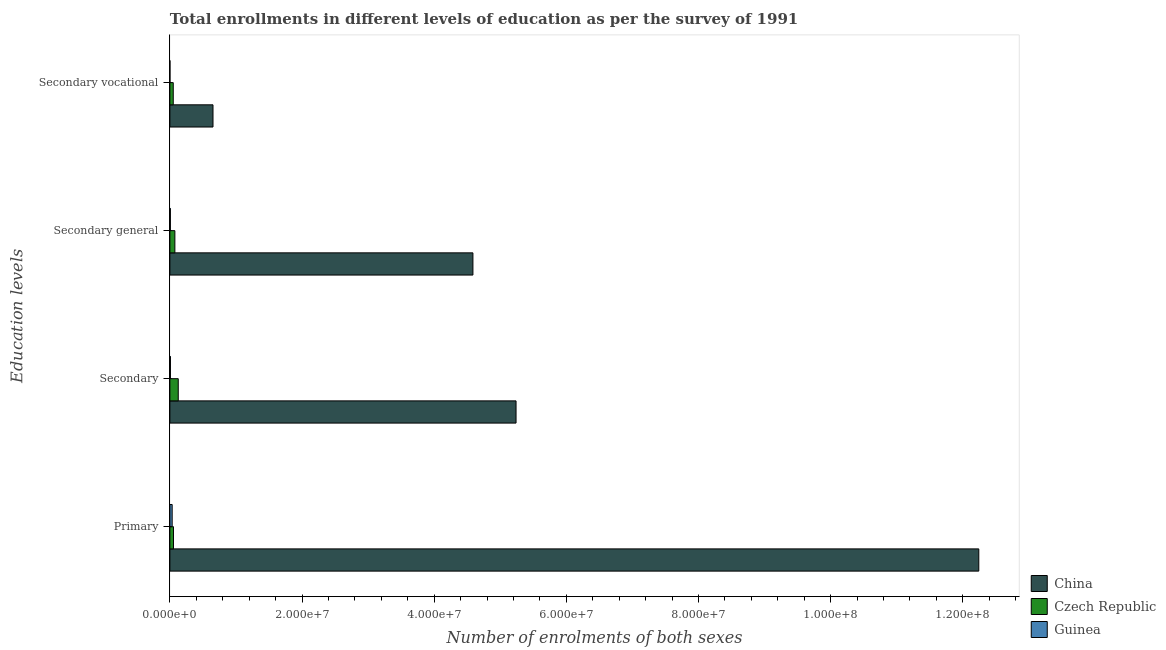How many different coloured bars are there?
Your answer should be compact. 3. How many groups of bars are there?
Ensure brevity in your answer.  4. Are the number of bars per tick equal to the number of legend labels?
Offer a very short reply. Yes. Are the number of bars on each tick of the Y-axis equal?
Offer a terse response. Yes. How many bars are there on the 2nd tick from the bottom?
Offer a very short reply. 3. What is the label of the 1st group of bars from the top?
Make the answer very short. Secondary vocational. What is the number of enrolments in secondary general education in Guinea?
Offer a terse response. 7.57e+04. Across all countries, what is the maximum number of enrolments in secondary general education?
Your response must be concise. 4.59e+07. Across all countries, what is the minimum number of enrolments in secondary education?
Offer a terse response. 8.59e+04. In which country was the number of enrolments in secondary education maximum?
Offer a very short reply. China. In which country was the number of enrolments in secondary vocational education minimum?
Your answer should be compact. Guinea. What is the total number of enrolments in secondary general education in the graph?
Provide a short and direct response. 4.67e+07. What is the difference between the number of enrolments in secondary education in Czech Republic and that in China?
Your response must be concise. -5.11e+07. What is the difference between the number of enrolments in secondary vocational education in China and the number of enrolments in secondary general education in Guinea?
Your answer should be compact. 6.45e+06. What is the average number of enrolments in primary education per country?
Your response must be concise. 4.11e+07. What is the difference between the number of enrolments in primary education and number of enrolments in secondary vocational education in Guinea?
Your response must be concise. 3.37e+05. In how many countries, is the number of enrolments in secondary general education greater than 56000000 ?
Keep it short and to the point. 0. What is the ratio of the number of enrolments in primary education in Czech Republic to that in Guinea?
Your answer should be compact. 1.57. Is the number of enrolments in secondary general education in China less than that in Guinea?
Your response must be concise. No. What is the difference between the highest and the second highest number of enrolments in secondary general education?
Ensure brevity in your answer.  4.51e+07. What is the difference between the highest and the lowest number of enrolments in secondary general education?
Ensure brevity in your answer.  4.58e+07. Is the sum of the number of enrolments in secondary vocational education in Czech Republic and Guinea greater than the maximum number of enrolments in secondary general education across all countries?
Offer a very short reply. No. Is it the case that in every country, the sum of the number of enrolments in primary education and number of enrolments in secondary education is greater than the number of enrolments in secondary general education?
Offer a terse response. Yes. Are all the bars in the graph horizontal?
Offer a very short reply. Yes. Are the values on the major ticks of X-axis written in scientific E-notation?
Your answer should be very brief. Yes. Does the graph contain any zero values?
Your response must be concise. No. How are the legend labels stacked?
Ensure brevity in your answer.  Vertical. What is the title of the graph?
Give a very brief answer. Total enrollments in different levels of education as per the survey of 1991. Does "Swaziland" appear as one of the legend labels in the graph?
Your answer should be very brief. No. What is the label or title of the X-axis?
Give a very brief answer. Number of enrolments of both sexes. What is the label or title of the Y-axis?
Offer a very short reply. Education levels. What is the Number of enrolments of both sexes in China in Primary?
Ensure brevity in your answer.  1.22e+08. What is the Number of enrolments of both sexes in Czech Republic in Primary?
Your answer should be very brief. 5.46e+05. What is the Number of enrolments of both sexes in Guinea in Primary?
Ensure brevity in your answer.  3.47e+05. What is the Number of enrolments of both sexes in China in Secondary?
Provide a short and direct response. 5.24e+07. What is the Number of enrolments of both sexes in Czech Republic in Secondary?
Your answer should be compact. 1.27e+06. What is the Number of enrolments of both sexes in Guinea in Secondary?
Offer a terse response. 8.59e+04. What is the Number of enrolments of both sexes in China in Secondary general?
Your response must be concise. 4.59e+07. What is the Number of enrolments of both sexes of Czech Republic in Secondary general?
Your answer should be very brief. 7.57e+05. What is the Number of enrolments of both sexes of Guinea in Secondary general?
Provide a succinct answer. 7.57e+04. What is the Number of enrolments of both sexes of China in Secondary vocational?
Give a very brief answer. 6.53e+06. What is the Number of enrolments of both sexes in Czech Republic in Secondary vocational?
Provide a succinct answer. 5.11e+05. What is the Number of enrolments of both sexes in Guinea in Secondary vocational?
Make the answer very short. 1.03e+04. Across all Education levels, what is the maximum Number of enrolments of both sexes in China?
Provide a short and direct response. 1.22e+08. Across all Education levels, what is the maximum Number of enrolments of both sexes of Czech Republic?
Give a very brief answer. 1.27e+06. Across all Education levels, what is the maximum Number of enrolments of both sexes in Guinea?
Offer a terse response. 3.47e+05. Across all Education levels, what is the minimum Number of enrolments of both sexes in China?
Your answer should be very brief. 6.53e+06. Across all Education levels, what is the minimum Number of enrolments of both sexes in Czech Republic?
Ensure brevity in your answer.  5.11e+05. Across all Education levels, what is the minimum Number of enrolments of both sexes in Guinea?
Provide a short and direct response. 1.03e+04. What is the total Number of enrolments of both sexes in China in the graph?
Your answer should be compact. 2.27e+08. What is the total Number of enrolments of both sexes of Czech Republic in the graph?
Offer a very short reply. 3.08e+06. What is the total Number of enrolments of both sexes of Guinea in the graph?
Your response must be concise. 5.19e+05. What is the difference between the Number of enrolments of both sexes in China in Primary and that in Secondary?
Offer a very short reply. 7.00e+07. What is the difference between the Number of enrolments of both sexes of Czech Republic in Primary and that in Secondary?
Make the answer very short. -7.22e+05. What is the difference between the Number of enrolments of both sexes of Guinea in Primary and that in Secondary?
Make the answer very short. 2.61e+05. What is the difference between the Number of enrolments of both sexes in China in Primary and that in Secondary general?
Give a very brief answer. 7.66e+07. What is the difference between the Number of enrolments of both sexes in Czech Republic in Primary and that in Secondary general?
Ensure brevity in your answer.  -2.11e+05. What is the difference between the Number of enrolments of both sexes of Guinea in Primary and that in Secondary general?
Provide a succinct answer. 2.71e+05. What is the difference between the Number of enrolments of both sexes in China in Primary and that in Secondary vocational?
Offer a terse response. 1.16e+08. What is the difference between the Number of enrolments of both sexes of Czech Republic in Primary and that in Secondary vocational?
Provide a succinct answer. 3.48e+04. What is the difference between the Number of enrolments of both sexes in Guinea in Primary and that in Secondary vocational?
Keep it short and to the point. 3.37e+05. What is the difference between the Number of enrolments of both sexes of China in Secondary and that in Secondary general?
Your answer should be compact. 6.53e+06. What is the difference between the Number of enrolments of both sexes in Czech Republic in Secondary and that in Secondary general?
Give a very brief answer. 5.11e+05. What is the difference between the Number of enrolments of both sexes in Guinea in Secondary and that in Secondary general?
Provide a short and direct response. 1.03e+04. What is the difference between the Number of enrolments of both sexes of China in Secondary and that in Secondary vocational?
Your answer should be very brief. 4.59e+07. What is the difference between the Number of enrolments of both sexes of Czech Republic in Secondary and that in Secondary vocational?
Provide a short and direct response. 7.57e+05. What is the difference between the Number of enrolments of both sexes of Guinea in Secondary and that in Secondary vocational?
Provide a short and direct response. 7.57e+04. What is the difference between the Number of enrolments of both sexes in China in Secondary general and that in Secondary vocational?
Ensure brevity in your answer.  3.93e+07. What is the difference between the Number of enrolments of both sexes of Czech Republic in Secondary general and that in Secondary vocational?
Offer a very short reply. 2.46e+05. What is the difference between the Number of enrolments of both sexes in Guinea in Secondary general and that in Secondary vocational?
Provide a succinct answer. 6.54e+04. What is the difference between the Number of enrolments of both sexes in China in Primary and the Number of enrolments of both sexes in Czech Republic in Secondary?
Offer a very short reply. 1.21e+08. What is the difference between the Number of enrolments of both sexes of China in Primary and the Number of enrolments of both sexes of Guinea in Secondary?
Offer a terse response. 1.22e+08. What is the difference between the Number of enrolments of both sexes of Czech Republic in Primary and the Number of enrolments of both sexes of Guinea in Secondary?
Ensure brevity in your answer.  4.60e+05. What is the difference between the Number of enrolments of both sexes of China in Primary and the Number of enrolments of both sexes of Czech Republic in Secondary general?
Your answer should be compact. 1.22e+08. What is the difference between the Number of enrolments of both sexes of China in Primary and the Number of enrolments of both sexes of Guinea in Secondary general?
Offer a very short reply. 1.22e+08. What is the difference between the Number of enrolments of both sexes of Czech Republic in Primary and the Number of enrolments of both sexes of Guinea in Secondary general?
Give a very brief answer. 4.70e+05. What is the difference between the Number of enrolments of both sexes of China in Primary and the Number of enrolments of both sexes of Czech Republic in Secondary vocational?
Your answer should be very brief. 1.22e+08. What is the difference between the Number of enrolments of both sexes in China in Primary and the Number of enrolments of both sexes in Guinea in Secondary vocational?
Give a very brief answer. 1.22e+08. What is the difference between the Number of enrolments of both sexes of Czech Republic in Primary and the Number of enrolments of both sexes of Guinea in Secondary vocational?
Offer a very short reply. 5.36e+05. What is the difference between the Number of enrolments of both sexes of China in Secondary and the Number of enrolments of both sexes of Czech Republic in Secondary general?
Give a very brief answer. 5.16e+07. What is the difference between the Number of enrolments of both sexes of China in Secondary and the Number of enrolments of both sexes of Guinea in Secondary general?
Keep it short and to the point. 5.23e+07. What is the difference between the Number of enrolments of both sexes in Czech Republic in Secondary and the Number of enrolments of both sexes in Guinea in Secondary general?
Keep it short and to the point. 1.19e+06. What is the difference between the Number of enrolments of both sexes of China in Secondary and the Number of enrolments of both sexes of Czech Republic in Secondary vocational?
Make the answer very short. 5.19e+07. What is the difference between the Number of enrolments of both sexes in China in Secondary and the Number of enrolments of both sexes in Guinea in Secondary vocational?
Provide a succinct answer. 5.24e+07. What is the difference between the Number of enrolments of both sexes of Czech Republic in Secondary and the Number of enrolments of both sexes of Guinea in Secondary vocational?
Keep it short and to the point. 1.26e+06. What is the difference between the Number of enrolments of both sexes of China in Secondary general and the Number of enrolments of both sexes of Czech Republic in Secondary vocational?
Offer a terse response. 4.53e+07. What is the difference between the Number of enrolments of both sexes in China in Secondary general and the Number of enrolments of both sexes in Guinea in Secondary vocational?
Offer a very short reply. 4.58e+07. What is the difference between the Number of enrolments of both sexes in Czech Republic in Secondary general and the Number of enrolments of both sexes in Guinea in Secondary vocational?
Your answer should be very brief. 7.46e+05. What is the average Number of enrolments of both sexes of China per Education levels?
Your response must be concise. 5.68e+07. What is the average Number of enrolments of both sexes in Czech Republic per Education levels?
Ensure brevity in your answer.  7.70e+05. What is the average Number of enrolments of both sexes in Guinea per Education levels?
Make the answer very short. 1.30e+05. What is the difference between the Number of enrolments of both sexes of China and Number of enrolments of both sexes of Czech Republic in Primary?
Give a very brief answer. 1.22e+08. What is the difference between the Number of enrolments of both sexes in China and Number of enrolments of both sexes in Guinea in Primary?
Your answer should be very brief. 1.22e+08. What is the difference between the Number of enrolments of both sexes of Czech Republic and Number of enrolments of both sexes of Guinea in Primary?
Your answer should be compact. 1.99e+05. What is the difference between the Number of enrolments of both sexes of China and Number of enrolments of both sexes of Czech Republic in Secondary?
Give a very brief answer. 5.11e+07. What is the difference between the Number of enrolments of both sexes in China and Number of enrolments of both sexes in Guinea in Secondary?
Provide a short and direct response. 5.23e+07. What is the difference between the Number of enrolments of both sexes of Czech Republic and Number of enrolments of both sexes of Guinea in Secondary?
Keep it short and to the point. 1.18e+06. What is the difference between the Number of enrolments of both sexes in China and Number of enrolments of both sexes in Czech Republic in Secondary general?
Make the answer very short. 4.51e+07. What is the difference between the Number of enrolments of both sexes in China and Number of enrolments of both sexes in Guinea in Secondary general?
Keep it short and to the point. 4.58e+07. What is the difference between the Number of enrolments of both sexes of Czech Republic and Number of enrolments of both sexes of Guinea in Secondary general?
Ensure brevity in your answer.  6.81e+05. What is the difference between the Number of enrolments of both sexes in China and Number of enrolments of both sexes in Czech Republic in Secondary vocational?
Keep it short and to the point. 6.01e+06. What is the difference between the Number of enrolments of both sexes in China and Number of enrolments of both sexes in Guinea in Secondary vocational?
Your answer should be compact. 6.52e+06. What is the difference between the Number of enrolments of both sexes in Czech Republic and Number of enrolments of both sexes in Guinea in Secondary vocational?
Offer a terse response. 5.01e+05. What is the ratio of the Number of enrolments of both sexes in China in Primary to that in Secondary?
Ensure brevity in your answer.  2.34. What is the ratio of the Number of enrolments of both sexes of Czech Republic in Primary to that in Secondary?
Give a very brief answer. 0.43. What is the ratio of the Number of enrolments of both sexes in Guinea in Primary to that in Secondary?
Provide a short and direct response. 4.04. What is the ratio of the Number of enrolments of both sexes in China in Primary to that in Secondary general?
Offer a very short reply. 2.67. What is the ratio of the Number of enrolments of both sexes in Czech Republic in Primary to that in Secondary general?
Your response must be concise. 0.72. What is the ratio of the Number of enrolments of both sexes in Guinea in Primary to that in Secondary general?
Your response must be concise. 4.58. What is the ratio of the Number of enrolments of both sexes in China in Primary to that in Secondary vocational?
Your answer should be very brief. 18.76. What is the ratio of the Number of enrolments of both sexes in Czech Republic in Primary to that in Secondary vocational?
Offer a very short reply. 1.07. What is the ratio of the Number of enrolments of both sexes in Guinea in Primary to that in Secondary vocational?
Give a very brief answer. 33.78. What is the ratio of the Number of enrolments of both sexes of China in Secondary to that in Secondary general?
Give a very brief answer. 1.14. What is the ratio of the Number of enrolments of both sexes of Czech Republic in Secondary to that in Secondary general?
Your response must be concise. 1.68. What is the ratio of the Number of enrolments of both sexes in Guinea in Secondary to that in Secondary general?
Your answer should be compact. 1.14. What is the ratio of the Number of enrolments of both sexes of China in Secondary to that in Secondary vocational?
Your response must be concise. 8.03. What is the ratio of the Number of enrolments of both sexes in Czech Republic in Secondary to that in Secondary vocational?
Ensure brevity in your answer.  2.48. What is the ratio of the Number of enrolments of both sexes in Guinea in Secondary to that in Secondary vocational?
Make the answer very short. 8.37. What is the ratio of the Number of enrolments of both sexes of China in Secondary general to that in Secondary vocational?
Ensure brevity in your answer.  7.03. What is the ratio of the Number of enrolments of both sexes in Czech Republic in Secondary general to that in Secondary vocational?
Provide a succinct answer. 1.48. What is the ratio of the Number of enrolments of both sexes in Guinea in Secondary general to that in Secondary vocational?
Provide a succinct answer. 7.37. What is the difference between the highest and the second highest Number of enrolments of both sexes of China?
Keep it short and to the point. 7.00e+07. What is the difference between the highest and the second highest Number of enrolments of both sexes of Czech Republic?
Keep it short and to the point. 5.11e+05. What is the difference between the highest and the second highest Number of enrolments of both sexes in Guinea?
Ensure brevity in your answer.  2.61e+05. What is the difference between the highest and the lowest Number of enrolments of both sexes in China?
Provide a short and direct response. 1.16e+08. What is the difference between the highest and the lowest Number of enrolments of both sexes of Czech Republic?
Your answer should be compact. 7.57e+05. What is the difference between the highest and the lowest Number of enrolments of both sexes of Guinea?
Your response must be concise. 3.37e+05. 